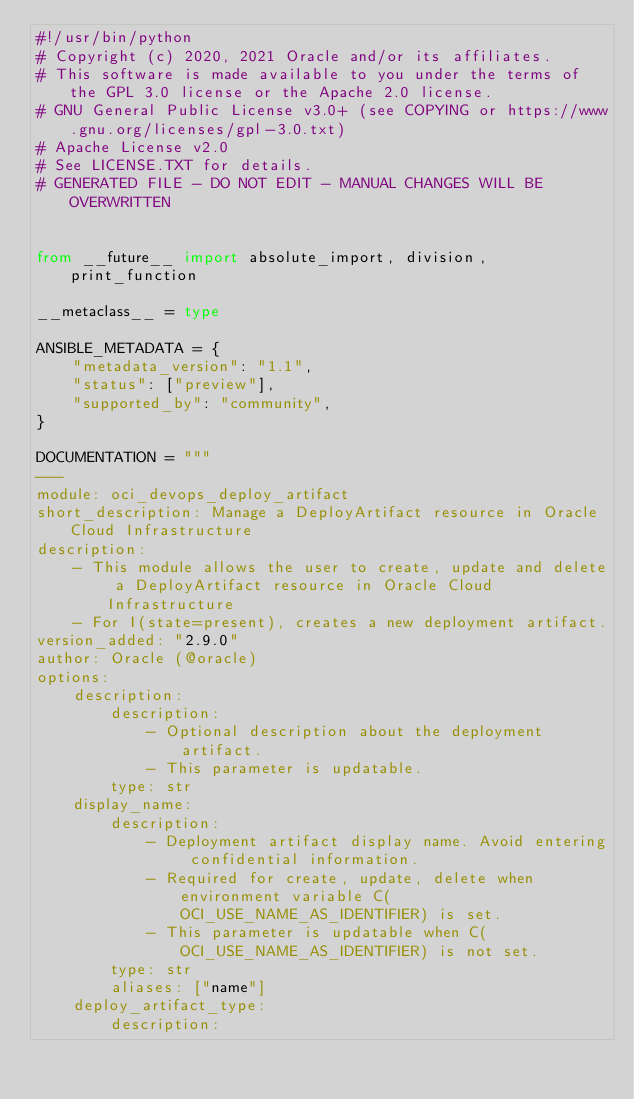Convert code to text. <code><loc_0><loc_0><loc_500><loc_500><_Python_>#!/usr/bin/python
# Copyright (c) 2020, 2021 Oracle and/or its affiliates.
# This software is made available to you under the terms of the GPL 3.0 license or the Apache 2.0 license.
# GNU General Public License v3.0+ (see COPYING or https://www.gnu.org/licenses/gpl-3.0.txt)
# Apache License v2.0
# See LICENSE.TXT for details.
# GENERATED FILE - DO NOT EDIT - MANUAL CHANGES WILL BE OVERWRITTEN


from __future__ import absolute_import, division, print_function

__metaclass__ = type

ANSIBLE_METADATA = {
    "metadata_version": "1.1",
    "status": ["preview"],
    "supported_by": "community",
}

DOCUMENTATION = """
---
module: oci_devops_deploy_artifact
short_description: Manage a DeployArtifact resource in Oracle Cloud Infrastructure
description:
    - This module allows the user to create, update and delete a DeployArtifact resource in Oracle Cloud Infrastructure
    - For I(state=present), creates a new deployment artifact.
version_added: "2.9.0"
author: Oracle (@oracle)
options:
    description:
        description:
            - Optional description about the deployment artifact.
            - This parameter is updatable.
        type: str
    display_name:
        description:
            - Deployment artifact display name. Avoid entering confidential information.
            - Required for create, update, delete when environment variable C(OCI_USE_NAME_AS_IDENTIFIER) is set.
            - This parameter is updatable when C(OCI_USE_NAME_AS_IDENTIFIER) is not set.
        type: str
        aliases: ["name"]
    deploy_artifact_type:
        description:</code> 